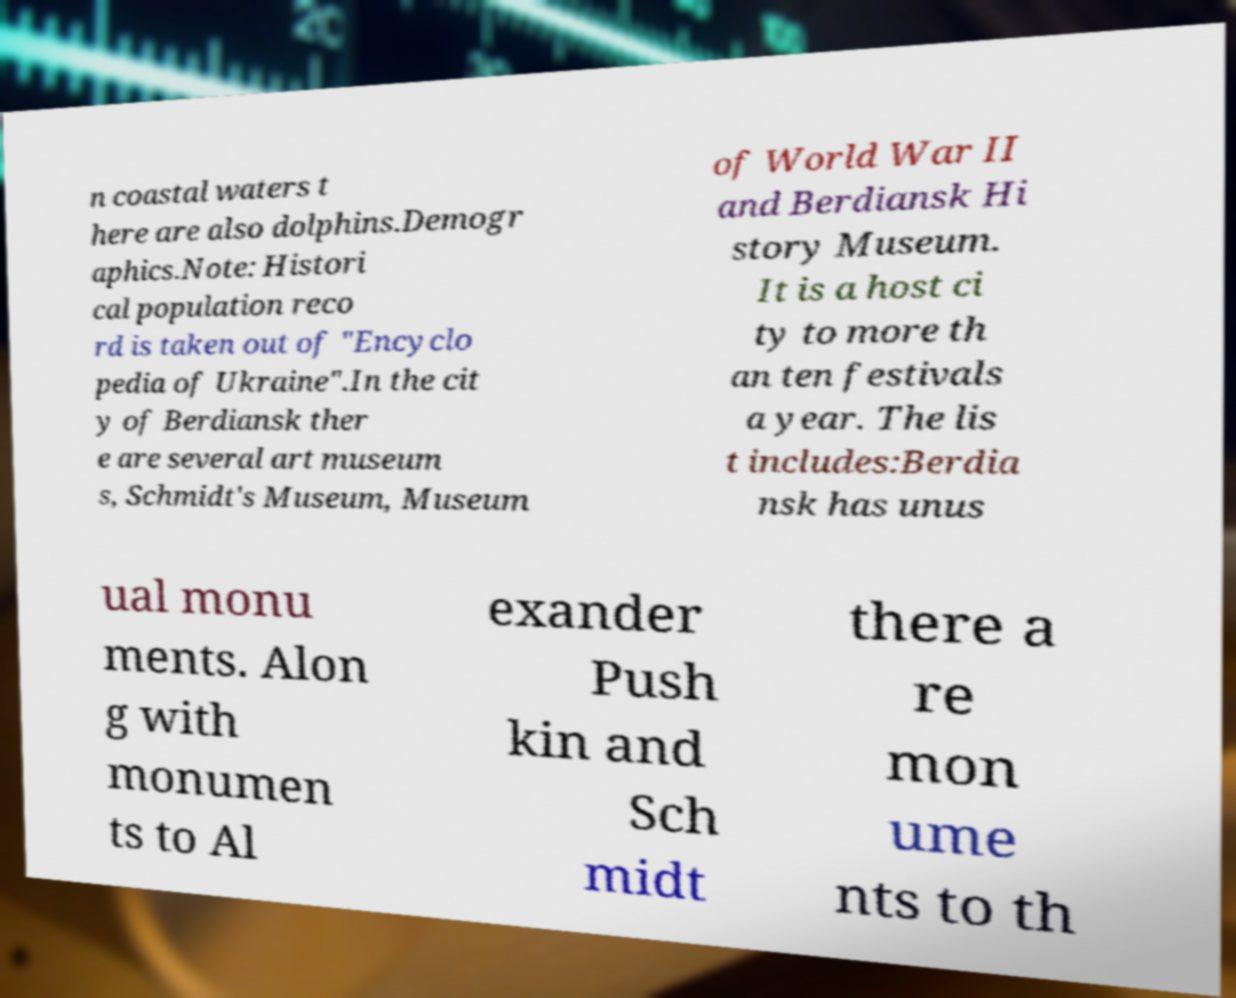Could you extract and type out the text from this image? n coastal waters t here are also dolphins.Demogr aphics.Note: Histori cal population reco rd is taken out of "Encyclo pedia of Ukraine".In the cit y of Berdiansk ther e are several art museum s, Schmidt's Museum, Museum of World War II and Berdiansk Hi story Museum. It is a host ci ty to more th an ten festivals a year. The lis t includes:Berdia nsk has unus ual monu ments. Alon g with monumen ts to Al exander Push kin and Sch midt there a re mon ume nts to th 